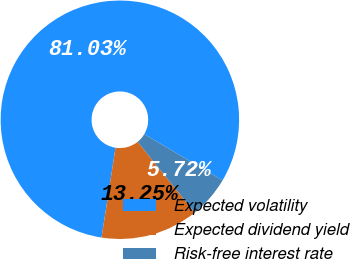Convert chart to OTSL. <chart><loc_0><loc_0><loc_500><loc_500><pie_chart><fcel>Expected volatility<fcel>Expected dividend yield<fcel>Risk-free interest rate<nl><fcel>81.02%<fcel>13.25%<fcel>5.72%<nl></chart> 